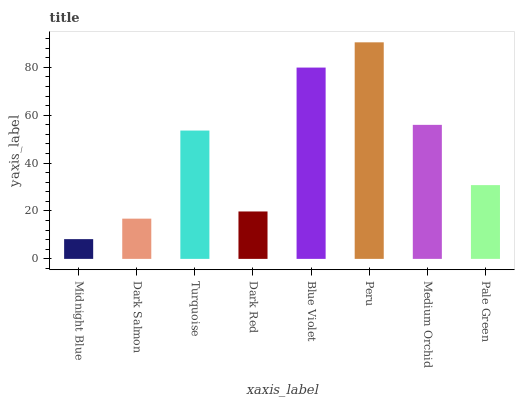Is Peru the maximum?
Answer yes or no. Yes. Is Dark Salmon the minimum?
Answer yes or no. No. Is Dark Salmon the maximum?
Answer yes or no. No. Is Dark Salmon greater than Midnight Blue?
Answer yes or no. Yes. Is Midnight Blue less than Dark Salmon?
Answer yes or no. Yes. Is Midnight Blue greater than Dark Salmon?
Answer yes or no. No. Is Dark Salmon less than Midnight Blue?
Answer yes or no. No. Is Turquoise the high median?
Answer yes or no. Yes. Is Pale Green the low median?
Answer yes or no. Yes. Is Dark Red the high median?
Answer yes or no. No. Is Turquoise the low median?
Answer yes or no. No. 